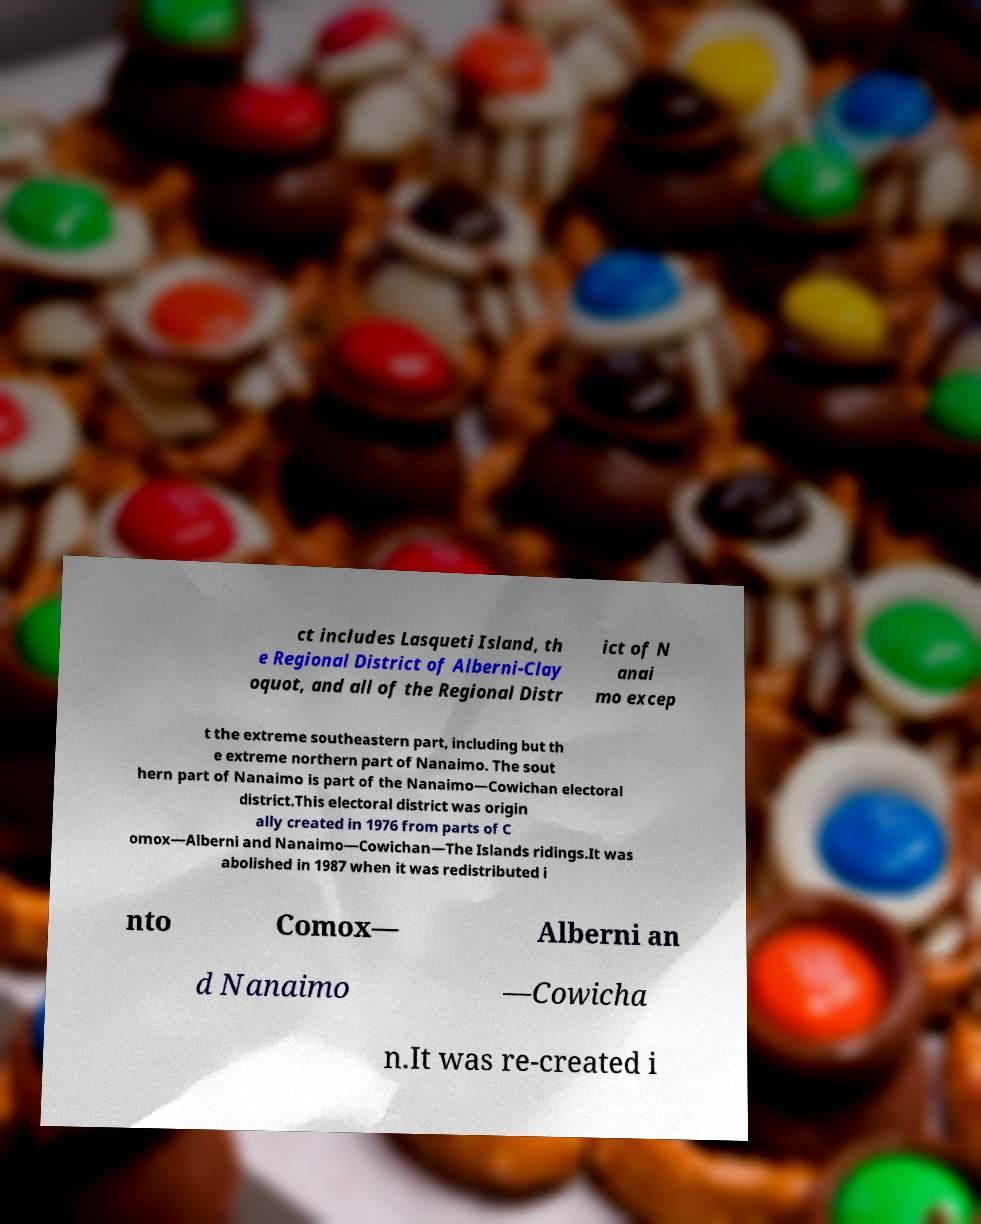There's text embedded in this image that I need extracted. Can you transcribe it verbatim? ct includes Lasqueti Island, th e Regional District of Alberni-Clay oquot, and all of the Regional Distr ict of N anai mo excep t the extreme southeastern part, including but th e extreme northern part of Nanaimo. The sout hern part of Nanaimo is part of the Nanaimo—Cowichan electoral district.This electoral district was origin ally created in 1976 from parts of C omox—Alberni and Nanaimo—Cowichan—The Islands ridings.It was abolished in 1987 when it was redistributed i nto Comox— Alberni an d Nanaimo —Cowicha n.It was re-created i 